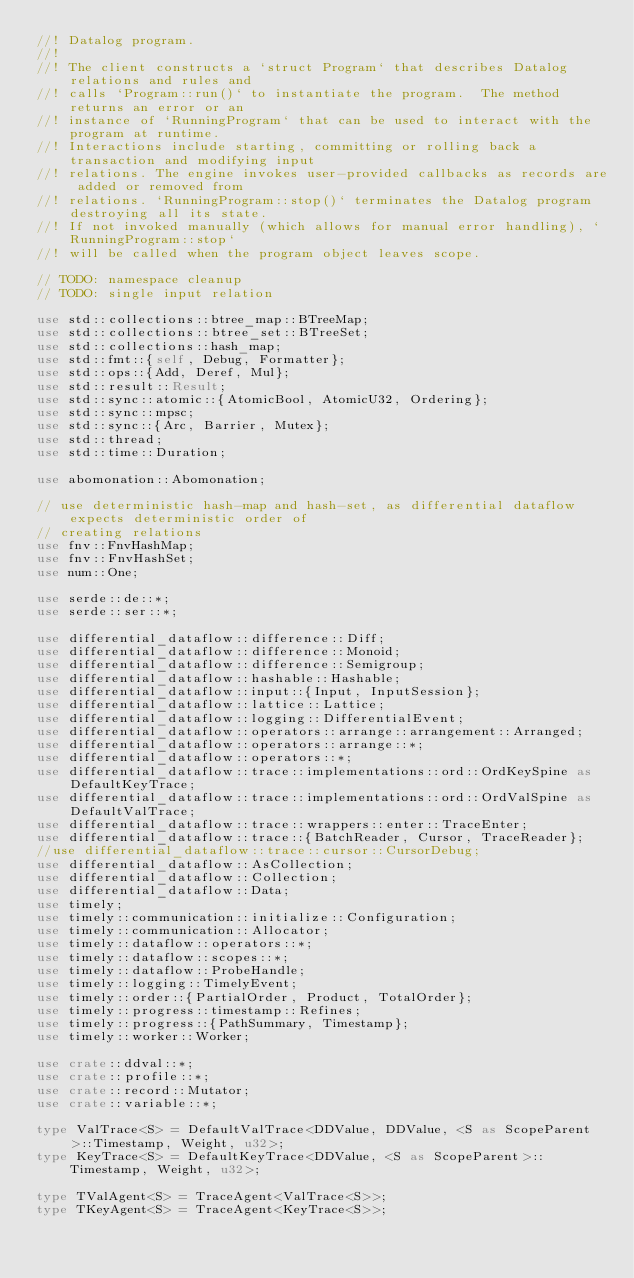Convert code to text. <code><loc_0><loc_0><loc_500><loc_500><_Rust_>//! Datalog program.
//!
//! The client constructs a `struct Program` that describes Datalog relations and rules and
//! calls `Program::run()` to instantiate the program.  The method returns an error or an
//! instance of `RunningProgram` that can be used to interact with the program at runtime.
//! Interactions include starting, committing or rolling back a transaction and modifying input
//! relations. The engine invokes user-provided callbacks as records are added or removed from
//! relations. `RunningProgram::stop()` terminates the Datalog program destroying all its state.
//! If not invoked manually (which allows for manual error handling), `RunningProgram::stop`
//! will be called when the program object leaves scope.

// TODO: namespace cleanup
// TODO: single input relation

use std::collections::btree_map::BTreeMap;
use std::collections::btree_set::BTreeSet;
use std::collections::hash_map;
use std::fmt::{self, Debug, Formatter};
use std::ops::{Add, Deref, Mul};
use std::result::Result;
use std::sync::atomic::{AtomicBool, AtomicU32, Ordering};
use std::sync::mpsc;
use std::sync::{Arc, Barrier, Mutex};
use std::thread;
use std::time::Duration;

use abomonation::Abomonation;

// use deterministic hash-map and hash-set, as differential dataflow expects deterministic order of
// creating relations
use fnv::FnvHashMap;
use fnv::FnvHashSet;
use num::One;

use serde::de::*;
use serde::ser::*;

use differential_dataflow::difference::Diff;
use differential_dataflow::difference::Monoid;
use differential_dataflow::difference::Semigroup;
use differential_dataflow::hashable::Hashable;
use differential_dataflow::input::{Input, InputSession};
use differential_dataflow::lattice::Lattice;
use differential_dataflow::logging::DifferentialEvent;
use differential_dataflow::operators::arrange::arrangement::Arranged;
use differential_dataflow::operators::arrange::*;
use differential_dataflow::operators::*;
use differential_dataflow::trace::implementations::ord::OrdKeySpine as DefaultKeyTrace;
use differential_dataflow::trace::implementations::ord::OrdValSpine as DefaultValTrace;
use differential_dataflow::trace::wrappers::enter::TraceEnter;
use differential_dataflow::trace::{BatchReader, Cursor, TraceReader};
//use differential_dataflow::trace::cursor::CursorDebug;
use differential_dataflow::AsCollection;
use differential_dataflow::Collection;
use differential_dataflow::Data;
use timely;
use timely::communication::initialize::Configuration;
use timely::communication::Allocator;
use timely::dataflow::operators::*;
use timely::dataflow::scopes::*;
use timely::dataflow::ProbeHandle;
use timely::logging::TimelyEvent;
use timely::order::{PartialOrder, Product, TotalOrder};
use timely::progress::timestamp::Refines;
use timely::progress::{PathSummary, Timestamp};
use timely::worker::Worker;

use crate::ddval::*;
use crate::profile::*;
use crate::record::Mutator;
use crate::variable::*;

type ValTrace<S> = DefaultValTrace<DDValue, DDValue, <S as ScopeParent>::Timestamp, Weight, u32>;
type KeyTrace<S> = DefaultKeyTrace<DDValue, <S as ScopeParent>::Timestamp, Weight, u32>;

type TValAgent<S> = TraceAgent<ValTrace<S>>;
type TKeyAgent<S> = TraceAgent<KeyTrace<S>>;
</code> 